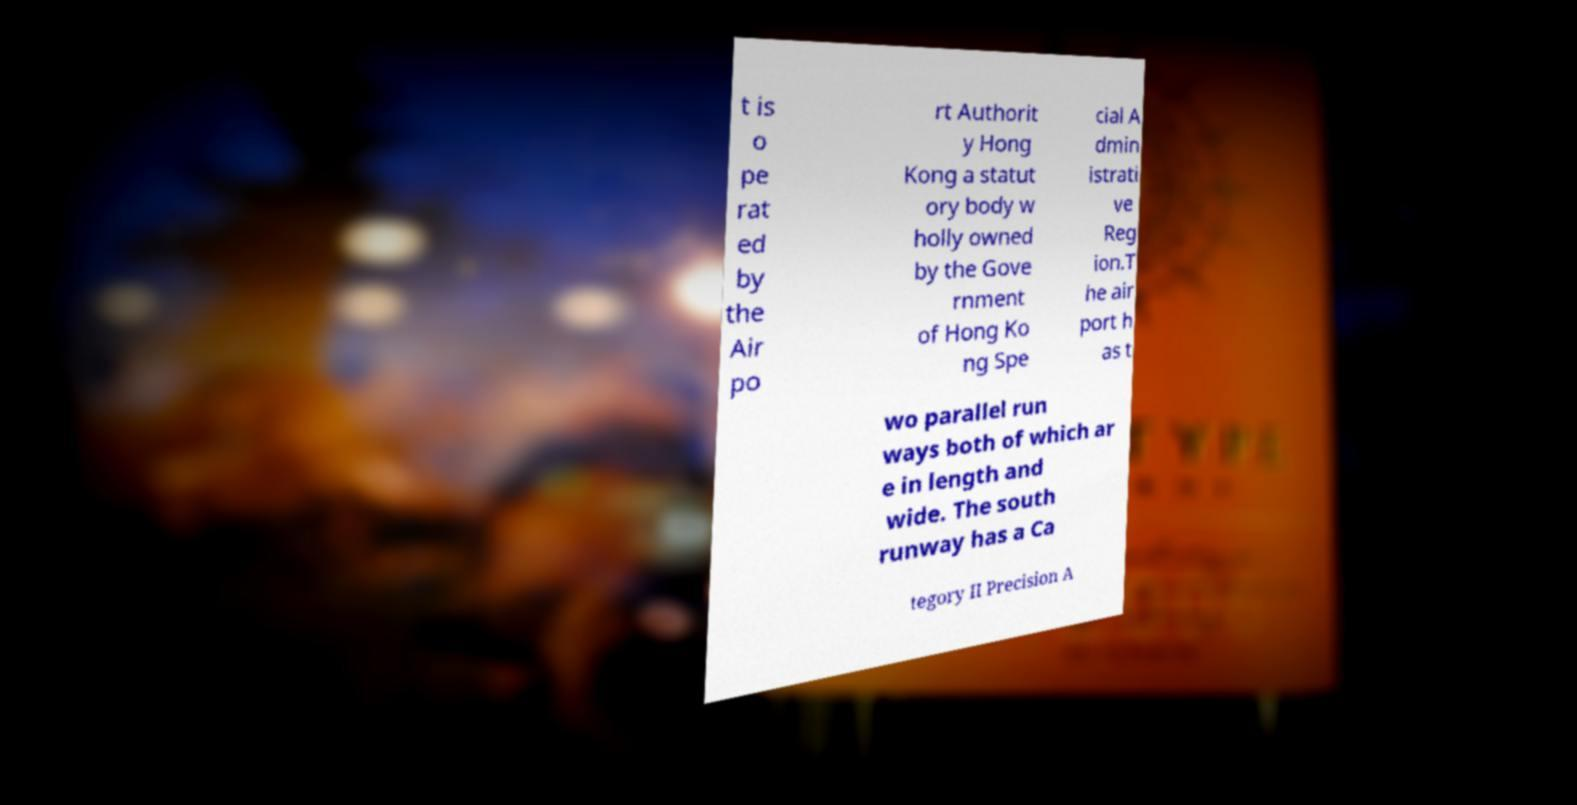There's text embedded in this image that I need extracted. Can you transcribe it verbatim? t is o pe rat ed by the Air po rt Authorit y Hong Kong a statut ory body w holly owned by the Gove rnment of Hong Ko ng Spe cial A dmin istrati ve Reg ion.T he air port h as t wo parallel run ways both of which ar e in length and wide. The south runway has a Ca tegory II Precision A 